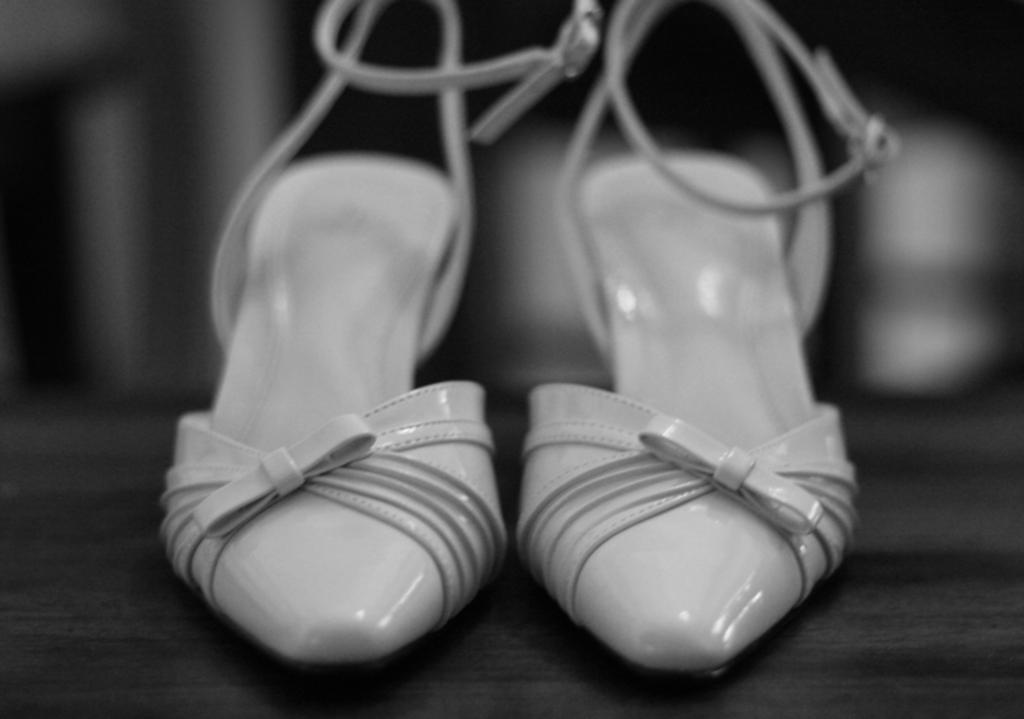Can you describe this image briefly? This is a black and white image. In the center of the image we can see sand heels are present on the floor. In the background the image is blur. 